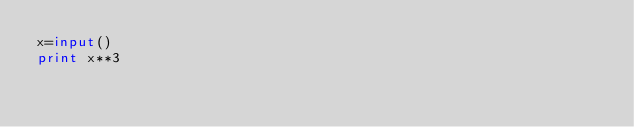<code> <loc_0><loc_0><loc_500><loc_500><_Python_>x=input()
print x**3</code> 